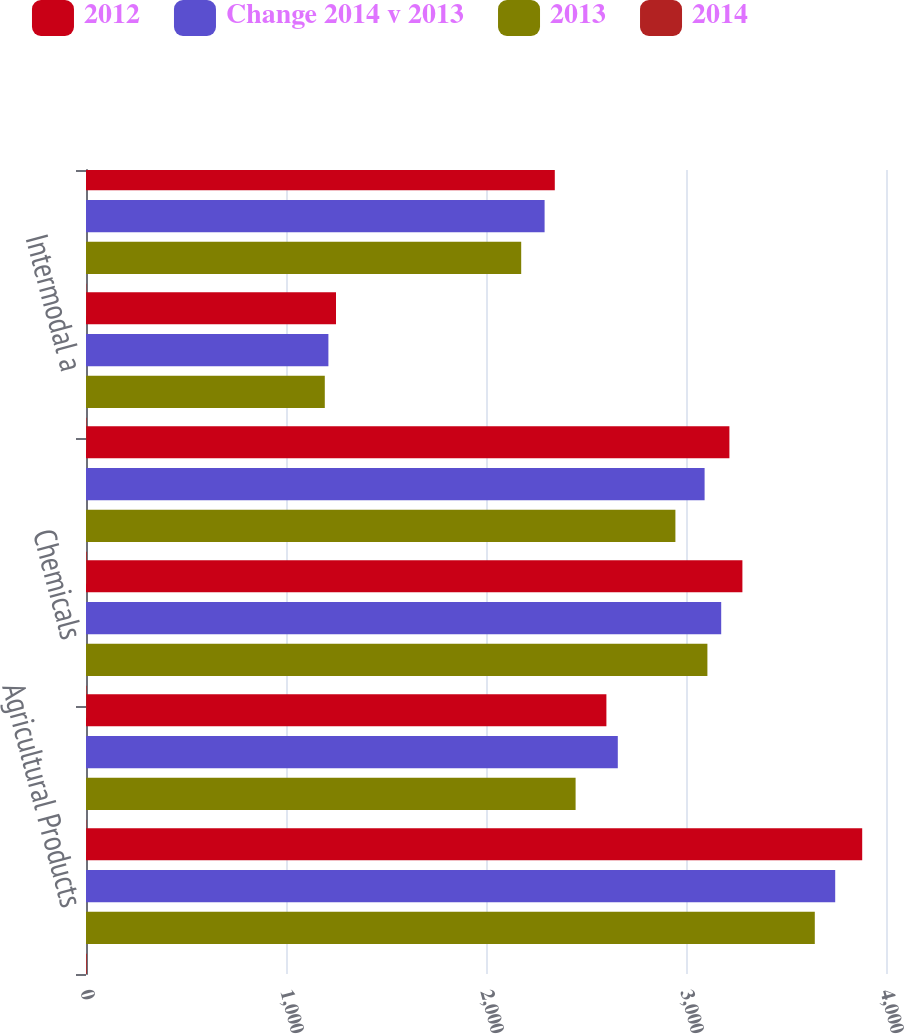Convert chart to OTSL. <chart><loc_0><loc_0><loc_500><loc_500><stacked_bar_chart><ecel><fcel>Agricultural Products<fcel>Automotive<fcel>Chemicals<fcel>Industrial Products<fcel>Intermodal a<fcel>Average<nl><fcel>2012<fcel>3881<fcel>2602<fcel>3282<fcel>3217<fcel>1250<fcel>2344<nl><fcel>Change 2014 v 2013<fcel>3746<fcel>2659<fcel>3176<fcel>3093<fcel>1212<fcel>2293<nl><fcel>2013<fcel>3644<fcel>2448<fcel>3107<fcel>2947<fcel>1194<fcel>2176<nl><fcel>2014<fcel>4<fcel>2<fcel>3<fcel>4<fcel>3<fcel>2<nl></chart> 